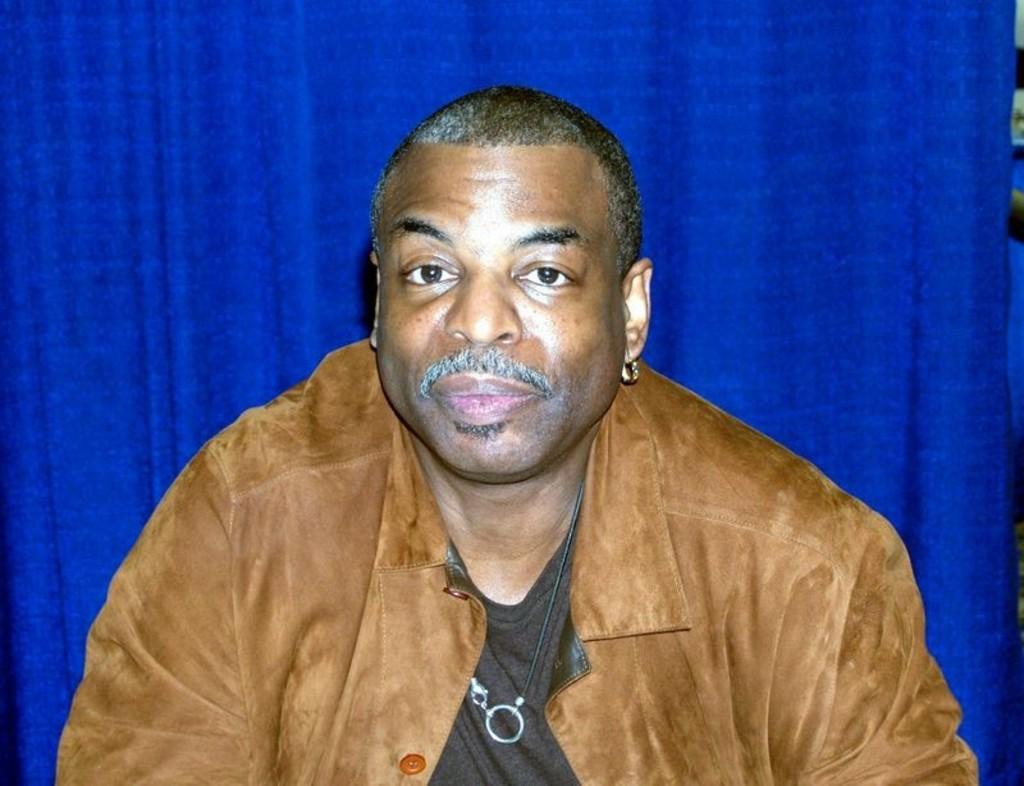Could you give a brief overview of what you see in this image? In the center of the image we can see a man wearing a jacket. In the background there is a curtain. 